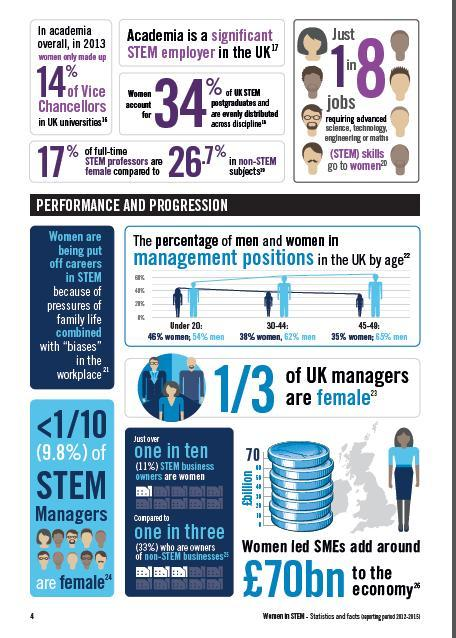What percentage of women under 20 are in the management position in UK?
Answer the question with a short phrase. 46% What percentage of women in the age group of 30-44 are in the management position in UK? 38% What percentage of men in the age group of 30-44 are in the management position in UK? 62% 